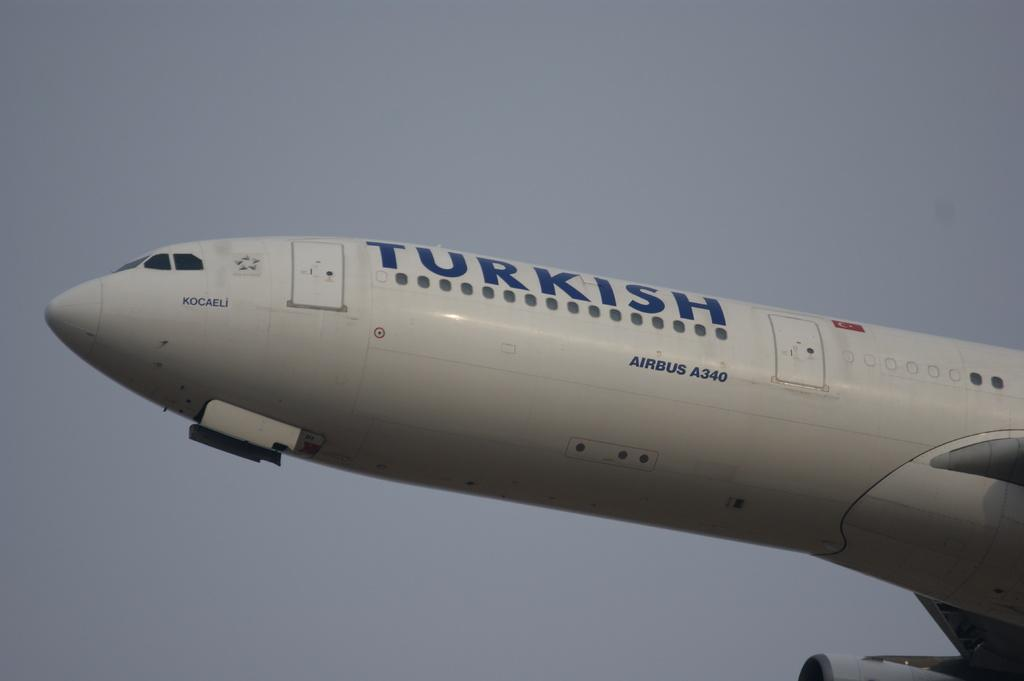<image>
Share a concise interpretation of the image provided. The plane flying in the air is definitely a Turkish plane. 